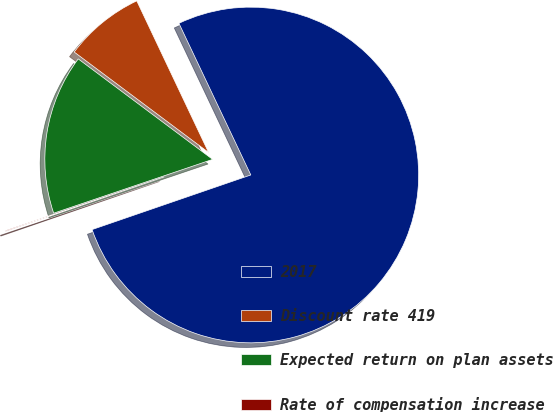<chart> <loc_0><loc_0><loc_500><loc_500><pie_chart><fcel>2017<fcel>Discount rate 419<fcel>Expected return on plan assets<fcel>Rate of compensation increase<nl><fcel>76.77%<fcel>7.74%<fcel>15.41%<fcel>0.08%<nl></chart> 